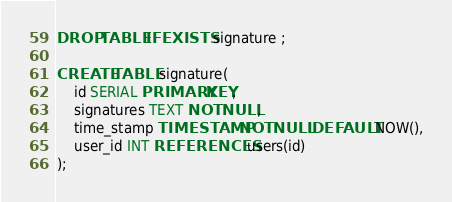<code> <loc_0><loc_0><loc_500><loc_500><_SQL_>DROP TABLE IF EXISTS signature ;

CREATE TABLE signature(
    id SERIAL PRIMARY KEY,
    signatures TEXT NOT NULL,
    time_stamp TIMESTAMP NOT NULL DEFAULT NOW(),
    user_id INT REFERENCES users(id) 
);</code> 